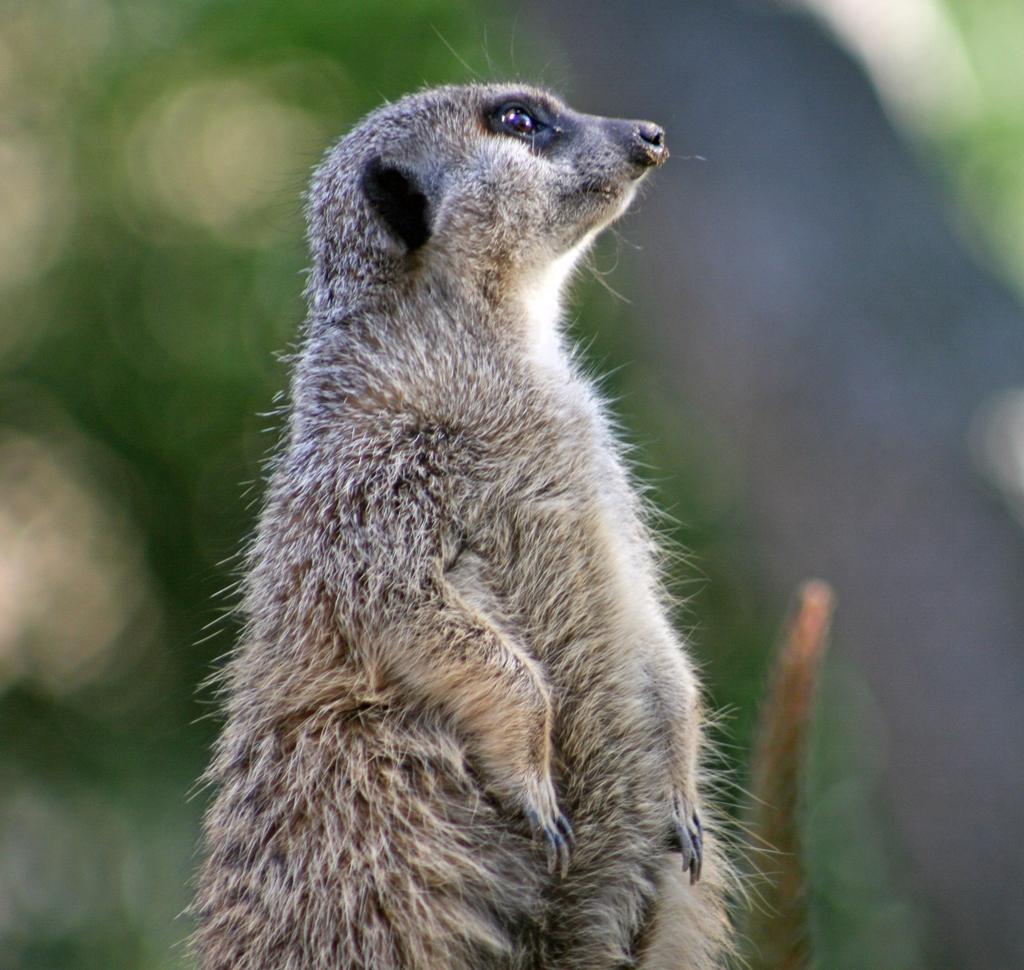Describe this image in one or two sentences. In this image there is a Meerkat truncated towards the bottom of the image, the background of the image is blurred. 